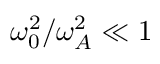Convert formula to latex. <formula><loc_0><loc_0><loc_500><loc_500>\omega _ { 0 } ^ { 2 } / \omega _ { A } ^ { 2 } \ll 1</formula> 